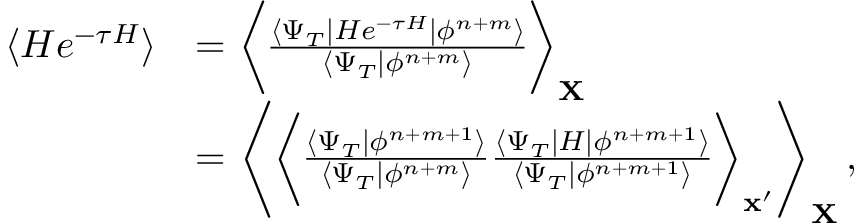Convert formula to latex. <formula><loc_0><loc_0><loc_500><loc_500>\begin{array} { r l } { \langle H e ^ { - \tau H } \rangle } & { = \left \langle \frac { \langle \Psi _ { T } | H e ^ { - \tau H } | \phi ^ { n + m } \rangle } { \langle \Psi _ { T } | \phi ^ { n + m } \rangle } \right \rangle _ { \mathbf X } } \\ & { = \left \langle \left \langle \frac { \langle \Psi _ { T } | \phi ^ { n + m + 1 } \rangle } { \langle \Psi _ { T } | \phi ^ { n + m } \rangle } \frac { \langle \Psi _ { T } | H | \phi ^ { n + m + 1 } \rangle } { \langle \Psi _ { T } | \phi ^ { n + m + 1 } \rangle } \right \rangle _ { \mathbf x ^ { \prime } } \right \rangle _ { \mathbf X } \, , } \end{array}</formula> 